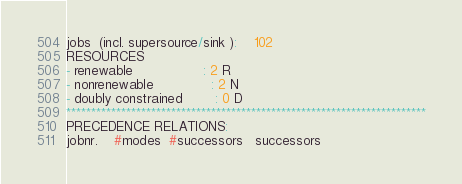<code> <loc_0><loc_0><loc_500><loc_500><_ObjectiveC_>jobs  (incl. supersource/sink ):	102
RESOURCES
- renewable                 : 2 R
- nonrenewable              : 2 N
- doubly constrained        : 0 D
************************************************************************
PRECEDENCE RELATIONS:
jobnr.    #modes  #successors   successors</code> 